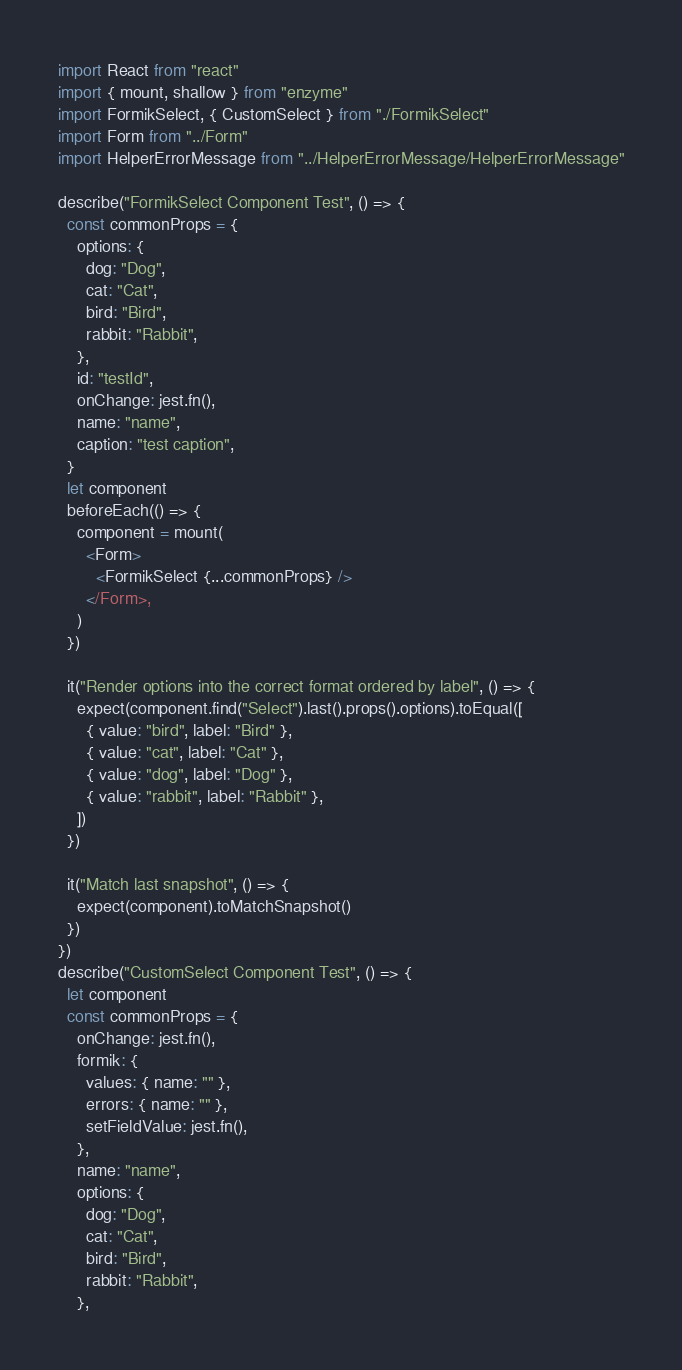Convert code to text. <code><loc_0><loc_0><loc_500><loc_500><_JavaScript_>import React from "react"
import { mount, shallow } from "enzyme"
import FormikSelect, { CustomSelect } from "./FormikSelect"
import Form from "../Form"
import HelperErrorMessage from "../HelperErrorMessage/HelperErrorMessage"

describe("FormikSelect Component Test", () => {
  const commonProps = {
    options: {
      dog: "Dog",
      cat: "Cat",
      bird: "Bird",
      rabbit: "Rabbit",
    },
    id: "testId",
    onChange: jest.fn(),
    name: "name",
    caption: "test caption",
  }
  let component
  beforeEach(() => {
    component = mount(
      <Form>
        <FormikSelect {...commonProps} />
      </Form>,
    )
  })

  it("Render options into the correct format ordered by label", () => {
    expect(component.find("Select").last().props().options).toEqual([
      { value: "bird", label: "Bird" },
      { value: "cat", label: "Cat" },
      { value: "dog", label: "Dog" },
      { value: "rabbit", label: "Rabbit" },
    ])
  })

  it("Match last snapshot", () => {
    expect(component).toMatchSnapshot()
  })
})
describe("CustomSelect Component Test", () => {
  let component
  const commonProps = {
    onChange: jest.fn(),
    formik: {
      values: { name: "" },
      errors: { name: "" },
      setFieldValue: jest.fn(),
    },
    name: "name",
    options: {
      dog: "Dog",
      cat: "Cat",
      bird: "Bird",
      rabbit: "Rabbit",
    },</code> 